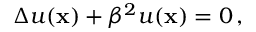<formula> <loc_0><loc_0><loc_500><loc_500>\Delta u ( { x } ) + \beta ^ { 2 } u ( { x } ) = 0 \, ,</formula> 